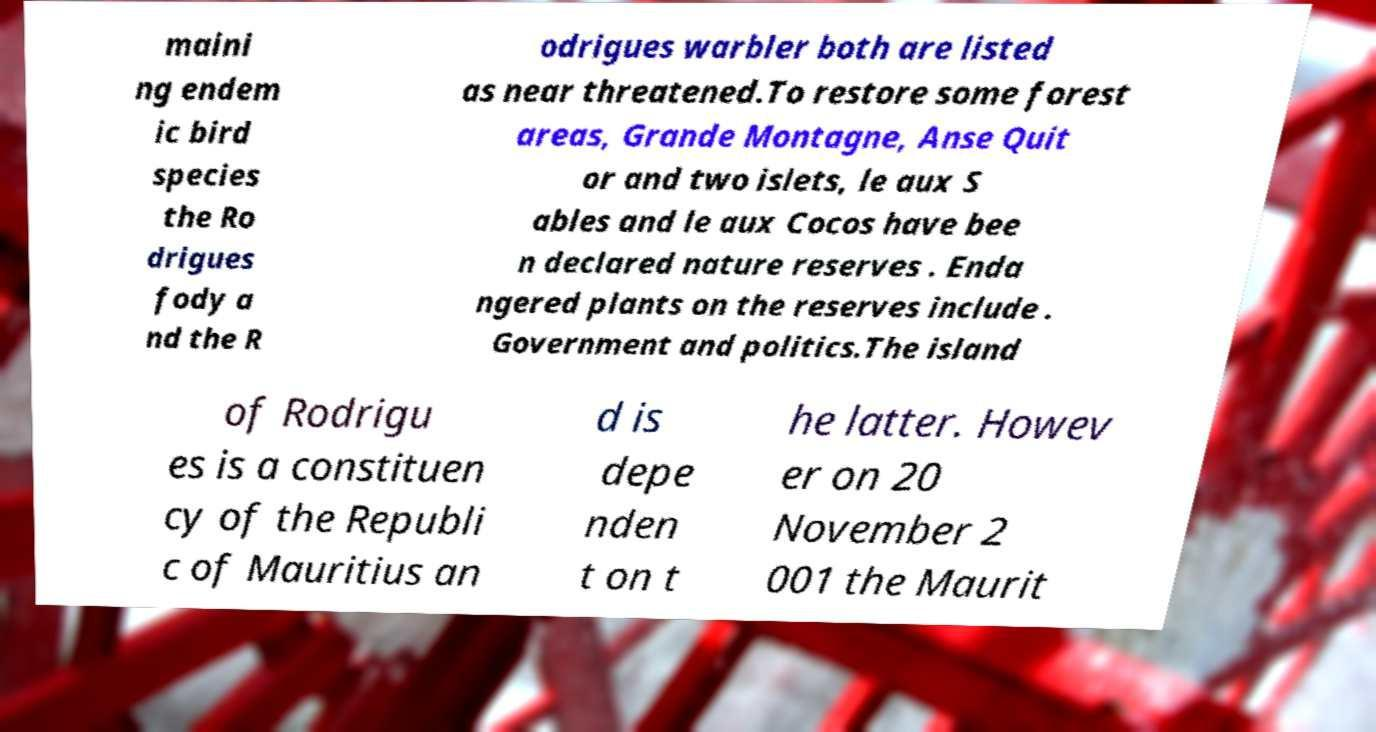Please read and relay the text visible in this image. What does it say? maini ng endem ic bird species the Ro drigues fody a nd the R odrigues warbler both are listed as near threatened.To restore some forest areas, Grande Montagne, Anse Quit or and two islets, le aux S ables and le aux Cocos have bee n declared nature reserves . Enda ngered plants on the reserves include . Government and politics.The island of Rodrigu es is a constituen cy of the Republi c of Mauritius an d is depe nden t on t he latter. Howev er on 20 November 2 001 the Maurit 